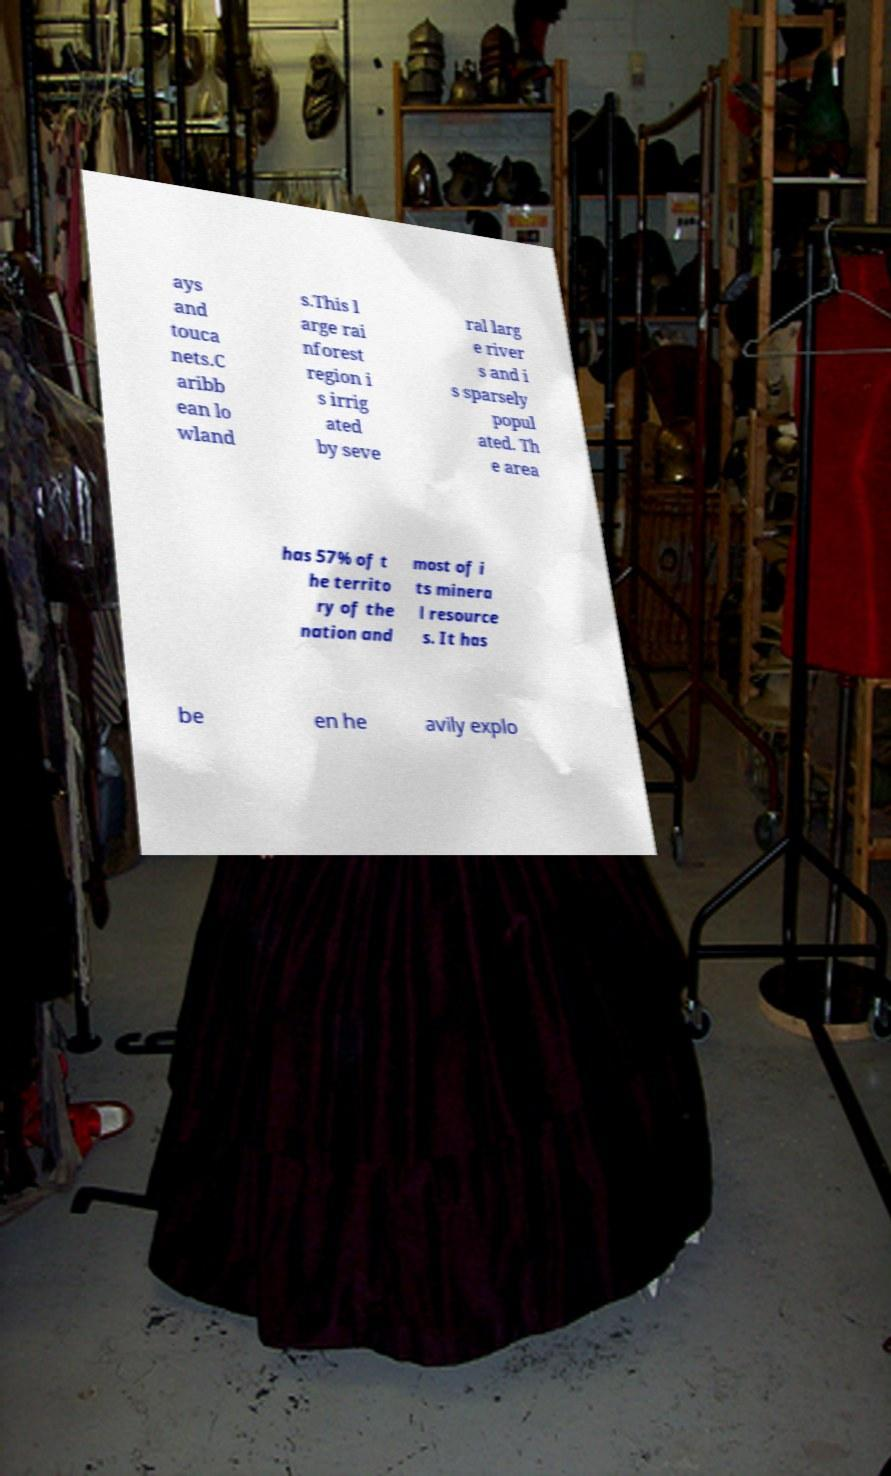What messages or text are displayed in this image? I need them in a readable, typed format. ays and touca nets.C aribb ean lo wland s.This l arge rai nforest region i s irrig ated by seve ral larg e river s and i s sparsely popul ated. Th e area has 57% of t he territo ry of the nation and most of i ts minera l resource s. It has be en he avily explo 